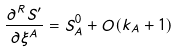Convert formula to latex. <formula><loc_0><loc_0><loc_500><loc_500>\frac { \partial ^ { R } S ^ { \prime } } { \partial \xi ^ { A } } = S _ { A } ^ { 0 } + O ( k _ { A } + 1 )</formula> 